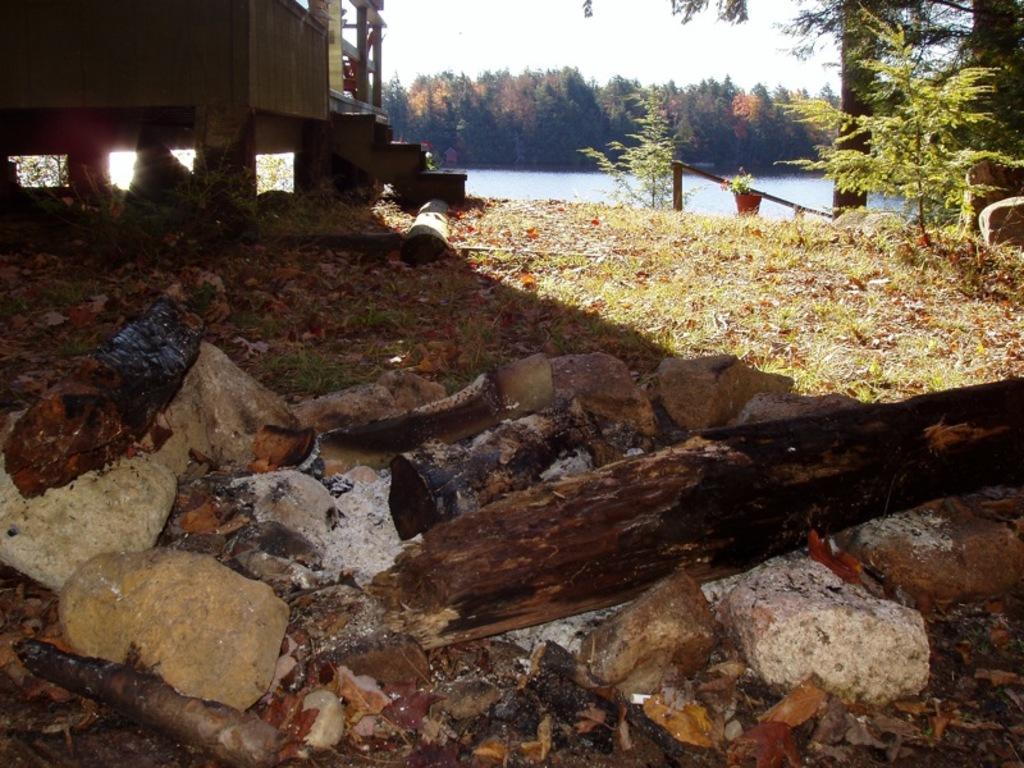Could you give a brief overview of what you see in this image? This image is taken outdoors. At the bottom of the image there is a ground with grass and a few dry leaves on it. In the background there are many trees and plants and there is a pond with water. At the top left of the image there is a wooden cabin and there are a few stones. At the top right of the image there are a few trees and plants and there is a plant in the pot. In the middle of the image there are a few stones and there is ash on the ground. 